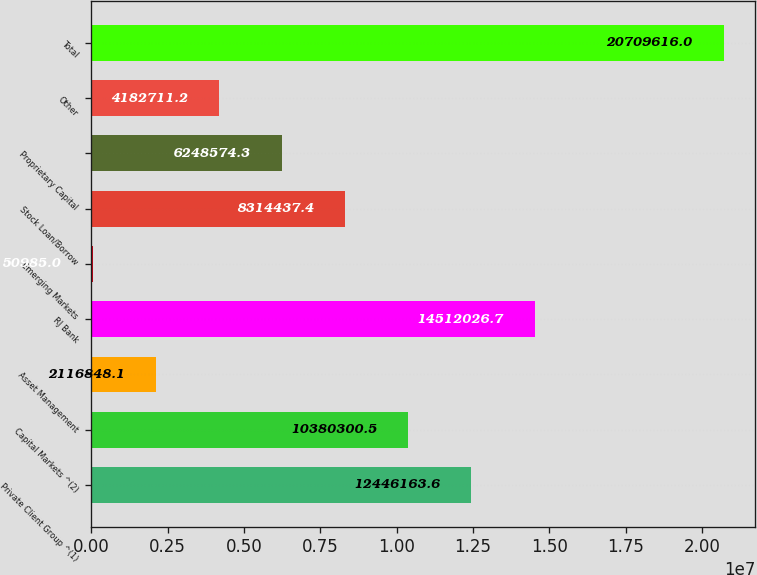Convert chart to OTSL. <chart><loc_0><loc_0><loc_500><loc_500><bar_chart><fcel>Private Client Group ^(1)<fcel>Capital Markets ^(2)<fcel>Asset Management<fcel>RJ Bank<fcel>Emerging Markets<fcel>Stock Loan/Borrow<fcel>Proprietary Capital<fcel>Other<fcel>Total<nl><fcel>1.24462e+07<fcel>1.03803e+07<fcel>2.11685e+06<fcel>1.4512e+07<fcel>50985<fcel>8.31444e+06<fcel>6.24857e+06<fcel>4.18271e+06<fcel>2.07096e+07<nl></chart> 